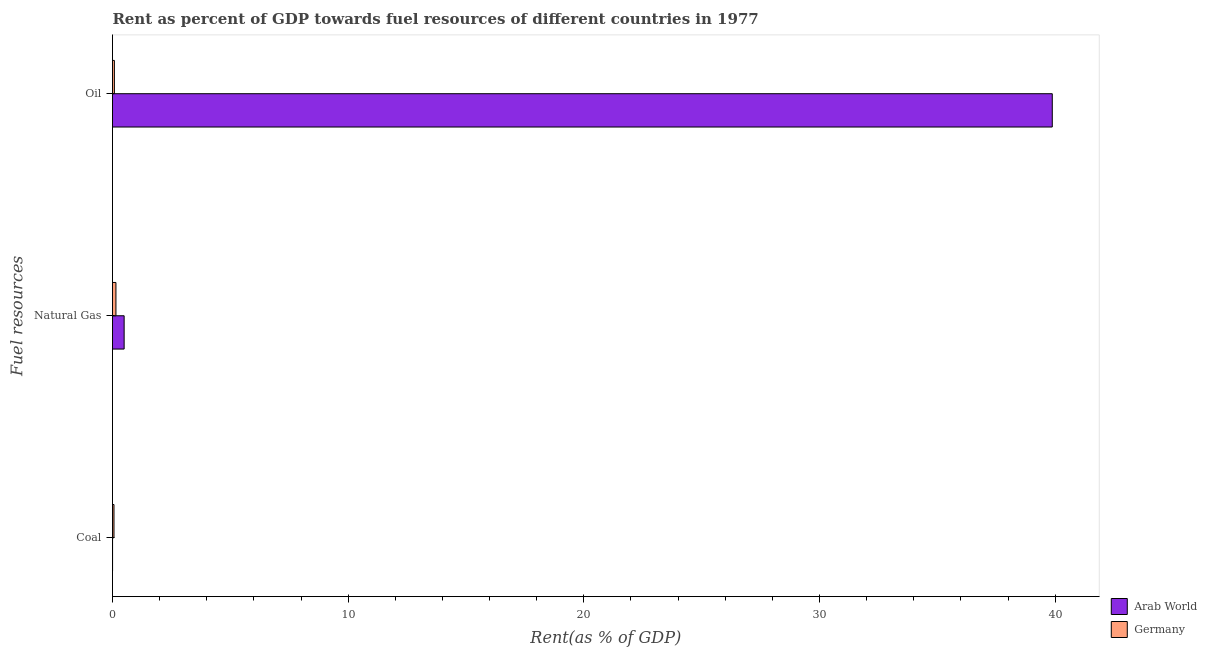What is the label of the 3rd group of bars from the top?
Ensure brevity in your answer.  Coal. What is the rent towards coal in Germany?
Offer a terse response. 0.06. Across all countries, what is the maximum rent towards natural gas?
Make the answer very short. 0.49. Across all countries, what is the minimum rent towards coal?
Provide a short and direct response. 0. In which country was the rent towards natural gas maximum?
Your response must be concise. Arab World. In which country was the rent towards coal minimum?
Provide a succinct answer. Arab World. What is the total rent towards natural gas in the graph?
Make the answer very short. 0.64. What is the difference between the rent towards coal in Germany and that in Arab World?
Your answer should be compact. 0.06. What is the difference between the rent towards coal in Germany and the rent towards oil in Arab World?
Offer a terse response. -39.82. What is the average rent towards natural gas per country?
Ensure brevity in your answer.  0.32. What is the difference between the rent towards coal and rent towards natural gas in Germany?
Your response must be concise. -0.08. In how many countries, is the rent towards natural gas greater than 32 %?
Your answer should be very brief. 0. What is the ratio of the rent towards oil in Germany to that in Arab World?
Provide a succinct answer. 0. What is the difference between the highest and the second highest rent towards natural gas?
Ensure brevity in your answer.  0.35. What is the difference between the highest and the lowest rent towards coal?
Keep it short and to the point. 0.06. Is the sum of the rent towards coal in Germany and Arab World greater than the maximum rent towards natural gas across all countries?
Offer a very short reply. No. Is it the case that in every country, the sum of the rent towards coal and rent towards natural gas is greater than the rent towards oil?
Keep it short and to the point. No. What is the difference between two consecutive major ticks on the X-axis?
Your answer should be very brief. 10. Does the graph contain any zero values?
Provide a short and direct response. No. Does the graph contain grids?
Ensure brevity in your answer.  No. How are the legend labels stacked?
Offer a terse response. Vertical. What is the title of the graph?
Offer a terse response. Rent as percent of GDP towards fuel resources of different countries in 1977. What is the label or title of the X-axis?
Ensure brevity in your answer.  Rent(as % of GDP). What is the label or title of the Y-axis?
Ensure brevity in your answer.  Fuel resources. What is the Rent(as % of GDP) in Arab World in Coal?
Provide a succinct answer. 0. What is the Rent(as % of GDP) of Germany in Coal?
Your answer should be compact. 0.06. What is the Rent(as % of GDP) of Arab World in Natural Gas?
Ensure brevity in your answer.  0.49. What is the Rent(as % of GDP) in Germany in Natural Gas?
Your answer should be very brief. 0.15. What is the Rent(as % of GDP) of Arab World in Oil?
Offer a very short reply. 39.88. What is the Rent(as % of GDP) of Germany in Oil?
Your answer should be compact. 0.08. Across all Fuel resources, what is the maximum Rent(as % of GDP) of Arab World?
Give a very brief answer. 39.88. Across all Fuel resources, what is the maximum Rent(as % of GDP) of Germany?
Make the answer very short. 0.15. Across all Fuel resources, what is the minimum Rent(as % of GDP) in Arab World?
Give a very brief answer. 0. Across all Fuel resources, what is the minimum Rent(as % of GDP) of Germany?
Provide a short and direct response. 0.06. What is the total Rent(as % of GDP) in Arab World in the graph?
Make the answer very short. 40.38. What is the total Rent(as % of GDP) in Germany in the graph?
Provide a short and direct response. 0.29. What is the difference between the Rent(as % of GDP) of Arab World in Coal and that in Natural Gas?
Your answer should be compact. -0.49. What is the difference between the Rent(as % of GDP) of Germany in Coal and that in Natural Gas?
Provide a succinct answer. -0.08. What is the difference between the Rent(as % of GDP) of Arab World in Coal and that in Oil?
Your response must be concise. -39.88. What is the difference between the Rent(as % of GDP) in Germany in Coal and that in Oil?
Your answer should be very brief. -0.02. What is the difference between the Rent(as % of GDP) in Arab World in Natural Gas and that in Oil?
Give a very brief answer. -39.39. What is the difference between the Rent(as % of GDP) in Germany in Natural Gas and that in Oil?
Give a very brief answer. 0.07. What is the difference between the Rent(as % of GDP) of Arab World in Coal and the Rent(as % of GDP) of Germany in Natural Gas?
Offer a terse response. -0.14. What is the difference between the Rent(as % of GDP) of Arab World in Coal and the Rent(as % of GDP) of Germany in Oil?
Offer a very short reply. -0.08. What is the difference between the Rent(as % of GDP) in Arab World in Natural Gas and the Rent(as % of GDP) in Germany in Oil?
Provide a succinct answer. 0.41. What is the average Rent(as % of GDP) of Arab World per Fuel resources?
Your answer should be compact. 13.46. What is the average Rent(as % of GDP) in Germany per Fuel resources?
Ensure brevity in your answer.  0.1. What is the difference between the Rent(as % of GDP) in Arab World and Rent(as % of GDP) in Germany in Coal?
Offer a very short reply. -0.06. What is the difference between the Rent(as % of GDP) in Arab World and Rent(as % of GDP) in Germany in Natural Gas?
Make the answer very short. 0.35. What is the difference between the Rent(as % of GDP) of Arab World and Rent(as % of GDP) of Germany in Oil?
Your answer should be very brief. 39.8. What is the ratio of the Rent(as % of GDP) in Arab World in Coal to that in Natural Gas?
Offer a terse response. 0. What is the ratio of the Rent(as % of GDP) of Germany in Coal to that in Natural Gas?
Ensure brevity in your answer.  0.43. What is the ratio of the Rent(as % of GDP) in Arab World in Coal to that in Oil?
Provide a succinct answer. 0. What is the ratio of the Rent(as % of GDP) of Germany in Coal to that in Oil?
Your answer should be very brief. 0.78. What is the ratio of the Rent(as % of GDP) in Arab World in Natural Gas to that in Oil?
Give a very brief answer. 0.01. What is the ratio of the Rent(as % of GDP) of Germany in Natural Gas to that in Oil?
Your answer should be compact. 1.82. What is the difference between the highest and the second highest Rent(as % of GDP) in Arab World?
Provide a succinct answer. 39.39. What is the difference between the highest and the second highest Rent(as % of GDP) of Germany?
Your answer should be very brief. 0.07. What is the difference between the highest and the lowest Rent(as % of GDP) of Arab World?
Offer a terse response. 39.88. What is the difference between the highest and the lowest Rent(as % of GDP) of Germany?
Offer a terse response. 0.08. 